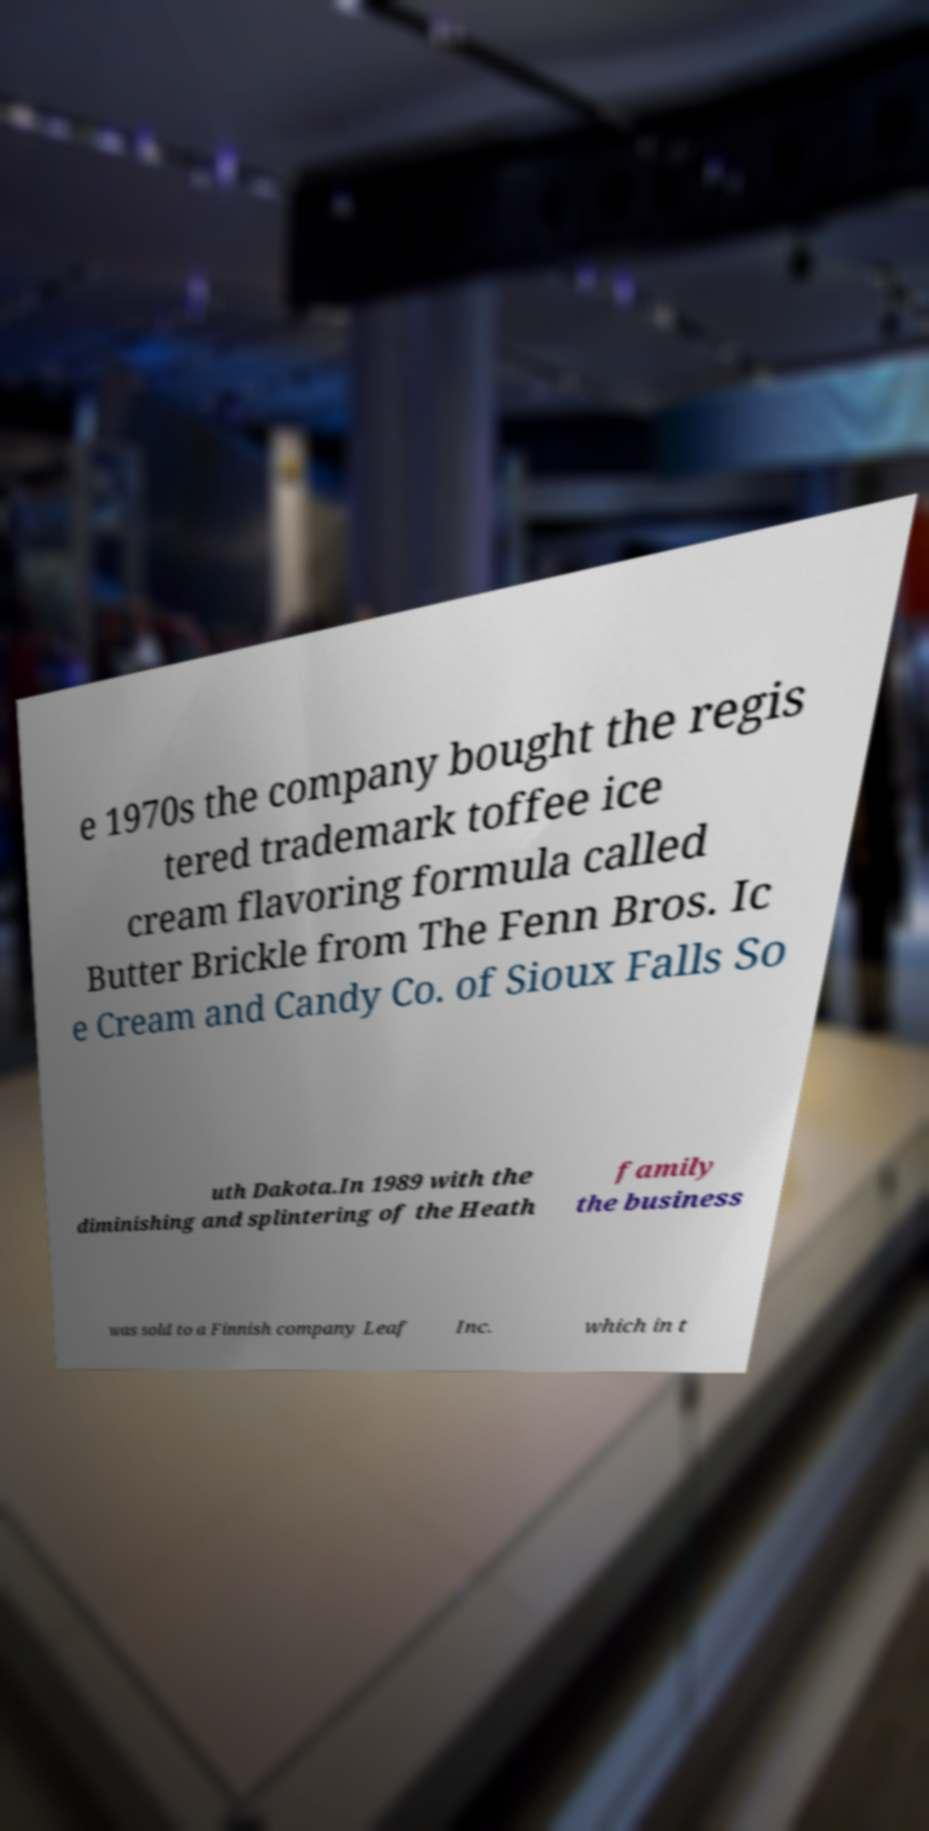For documentation purposes, I need the text within this image transcribed. Could you provide that? e 1970s the company bought the regis tered trademark toffee ice cream flavoring formula called Butter Brickle from The Fenn Bros. Ic e Cream and Candy Co. of Sioux Falls So uth Dakota.In 1989 with the diminishing and splintering of the Heath family the business was sold to a Finnish company Leaf Inc. which in t 